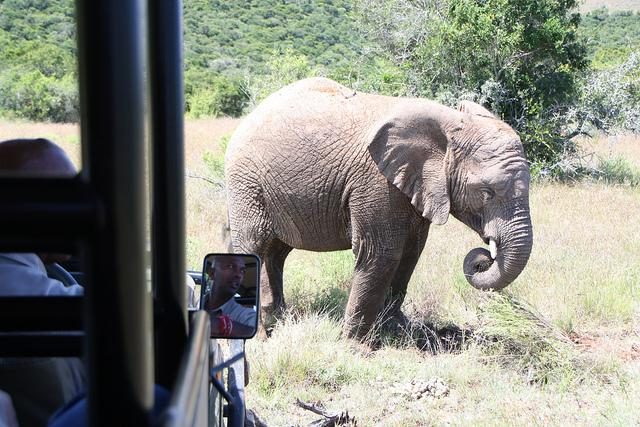What type of vehicle is the man on the left most likely riding in?

Choices:
A) jeep
B) sedan
C) tour bus
D) convertible jeep 